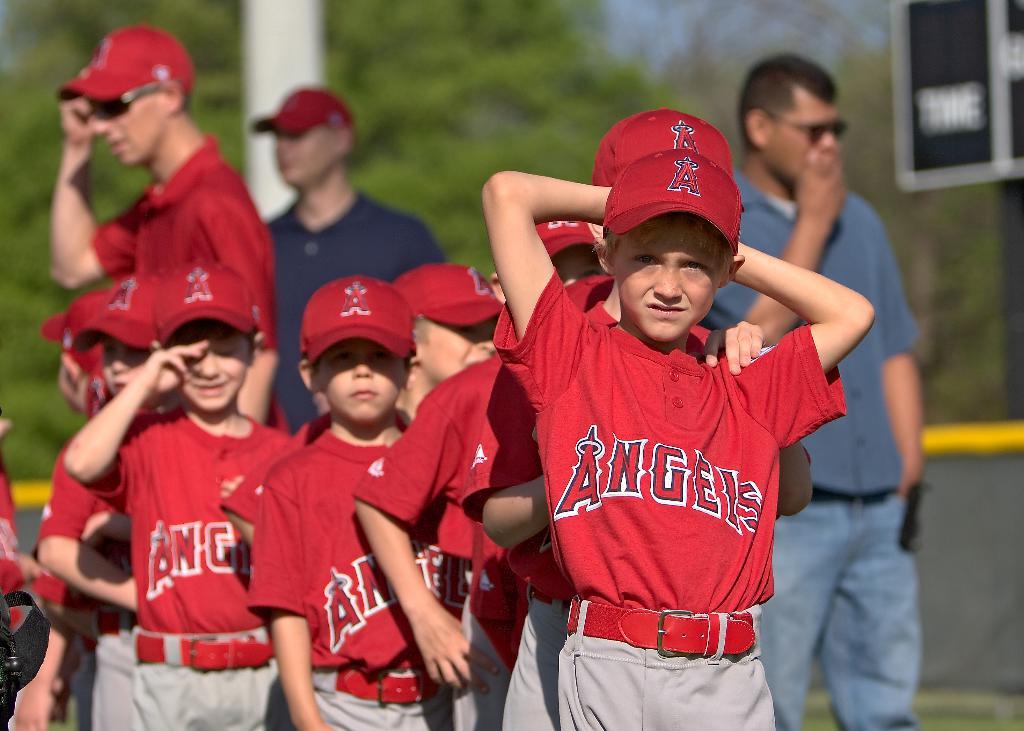What team name do they play for?
Provide a short and direct response. Angels. What letter is on their hats?
Give a very brief answer. A. 